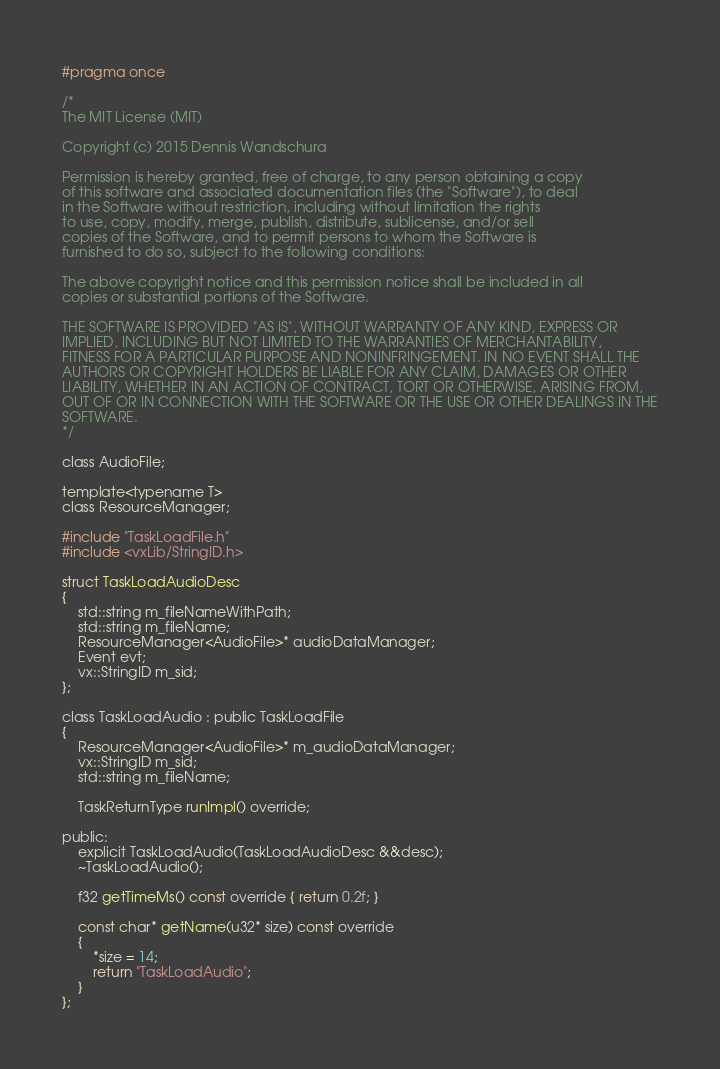<code> <loc_0><loc_0><loc_500><loc_500><_C_>#pragma once

/*
The MIT License (MIT)

Copyright (c) 2015 Dennis Wandschura

Permission is hereby granted, free of charge, to any person obtaining a copy
of this software and associated documentation files (the "Software"), to deal
in the Software without restriction, including without limitation the rights
to use, copy, modify, merge, publish, distribute, sublicense, and/or sell
copies of the Software, and to permit persons to whom the Software is
furnished to do so, subject to the following conditions:

The above copyright notice and this permission notice shall be included in all
copies or substantial portions of the Software.

THE SOFTWARE IS PROVIDED "AS IS", WITHOUT WARRANTY OF ANY KIND, EXPRESS OR
IMPLIED, INCLUDING BUT NOT LIMITED TO THE WARRANTIES OF MERCHANTABILITY,
FITNESS FOR A PARTICULAR PURPOSE AND NONINFRINGEMENT. IN NO EVENT SHALL THE
AUTHORS OR COPYRIGHT HOLDERS BE LIABLE FOR ANY CLAIM, DAMAGES OR OTHER
LIABILITY, WHETHER IN AN ACTION OF CONTRACT, TORT OR OTHERWISE, ARISING FROM,
OUT OF OR IN CONNECTION WITH THE SOFTWARE OR THE USE OR OTHER DEALINGS IN THE
SOFTWARE.
*/

class AudioFile;

template<typename T>
class ResourceManager;

#include "TaskLoadFile.h"
#include <vxLib/StringID.h>

struct TaskLoadAudioDesc
{
	std::string m_fileNameWithPath;
	std::string m_fileName;
	ResourceManager<AudioFile>* audioDataManager;
	Event evt;
	vx::StringID m_sid;
};

class TaskLoadAudio : public TaskLoadFile
{
	ResourceManager<AudioFile>* m_audioDataManager;
	vx::StringID m_sid;
	std::string m_fileName;

	TaskReturnType runImpl() override;

public:
	explicit TaskLoadAudio(TaskLoadAudioDesc &&desc);
	~TaskLoadAudio();

	f32 getTimeMs() const override { return 0.2f; }

	const char* getName(u32* size) const override
	{
		*size = 14;
		return "TaskLoadAudio";
	}
};</code> 